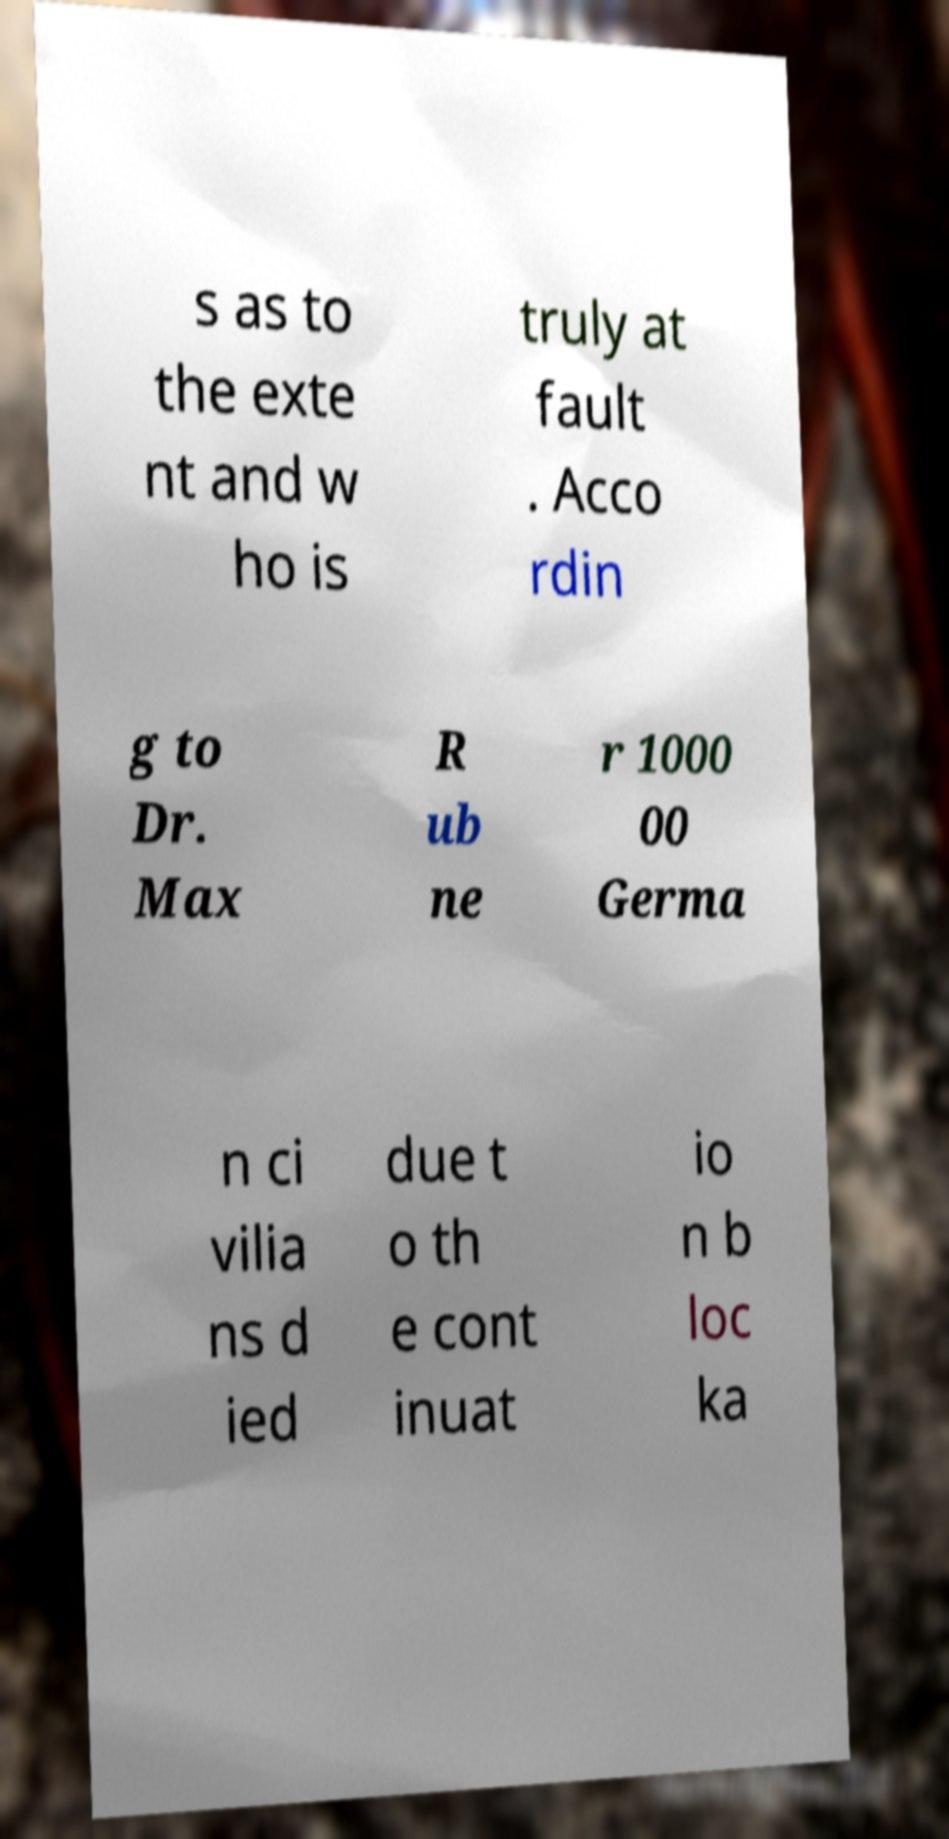For documentation purposes, I need the text within this image transcribed. Could you provide that? s as to the exte nt and w ho is truly at fault . Acco rdin g to Dr. Max R ub ne r 1000 00 Germa n ci vilia ns d ied due t o th e cont inuat io n b loc ka 